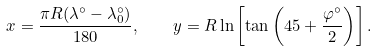Convert formula to latex. <formula><loc_0><loc_0><loc_500><loc_500>x = { \frac { \pi R ( \lambda ^ { \circ } - \lambda _ { 0 } ^ { \circ } ) } { 1 8 0 } } , \quad y = R \ln \left [ \tan \left ( 4 5 + { \frac { \varphi ^ { \circ } } { 2 } } \right ) \right ] .</formula> 